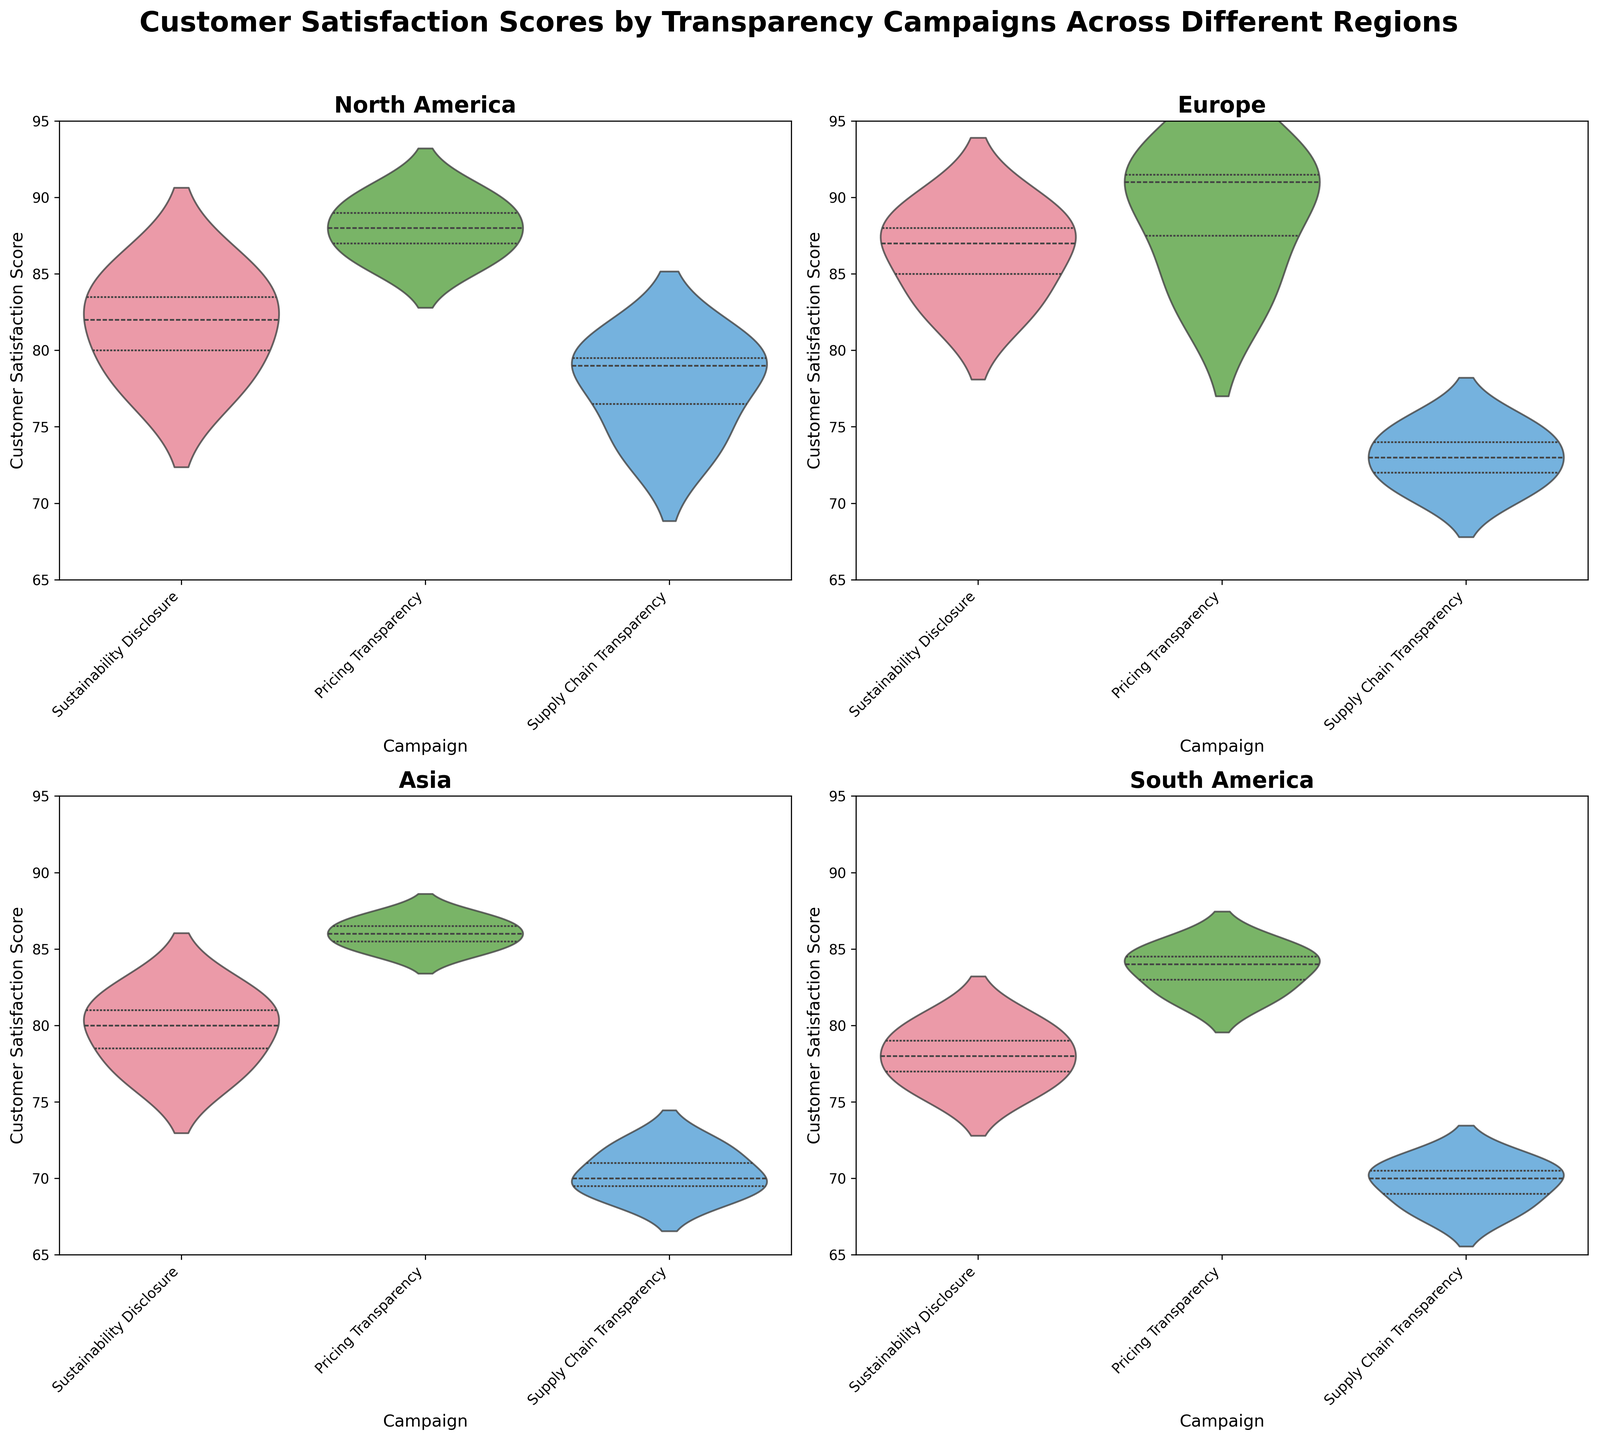What is the title of the figure? The title of the figure is displayed at the top in bold and large font. It states the overall topic of the figure, providing context about what's being visualized.
Answer: Customer Satisfaction Scores by Transparency Campaigns Across Different Regions Which region has the highest median customer satisfaction score for the "Sustainability Disclosure" campaign? To find the highest median customer satisfaction score, look at the middle line (representing the median) in the violin plots for the "Sustainability Disclosure" campaign in each region. Compare these median lines.
Answer: Europe How many different campaigns are visualized in each subplot? Each subplot represents data for a different region and contains multiple violin plots. Count the number of distinct violin plots (each corresponding to a campaign) in any one subplot.
Answer: 3 Which region has the most spread (widest range) in customer satisfaction scores for the "Supply Chain Transparency" campaign? Look at the width of the violin plots representing the "Supply Chain Transparency" campaign in each region. The region with the widest violin plot has the most spread.
Answer: Asia What is the range of customer satisfaction scores for the "Pricing Transparency" campaign in North America? Observe the violin plot for "Pricing Transparency" in the North America subplot. Look at the top and bottom of the plot to determine the range of scores.
Answer: 86-90 Which transparency campaign generally results in the lowest customer satisfaction scores across all regions? Look at all the violin plots and identify which campaign has the lowest median lines and lowest spread across all regions.
Answer: Supply Chain Transparency Compare the median customer satisfaction scores for the "Pricing Transparency" campaign between Europe and Asia. Which region has a higher median score? Look at the median lines within the violin plots for the "Pricing Transparency" campaign in Europe and Asia subplots and compare their heights.
Answer: Europe Is there any region where the "Sustainability Disclosure" campaign has the lowest customer satisfaction scores compared to other campaigns in the same region? For each region, compare the median lines and the range of the "Sustainability Disclosure" campaign with the other campaigns. Identify any region where "Sustainability Disclosure" is the lowest.
Answer: No What's the median customer satisfaction score for the "Supply Chain Transparency" campaign in South America? Look at the middle line inside the violin plot for the "Supply Chain Transparency" campaign in the South America subplot to identify the median score.
Answer: 70 